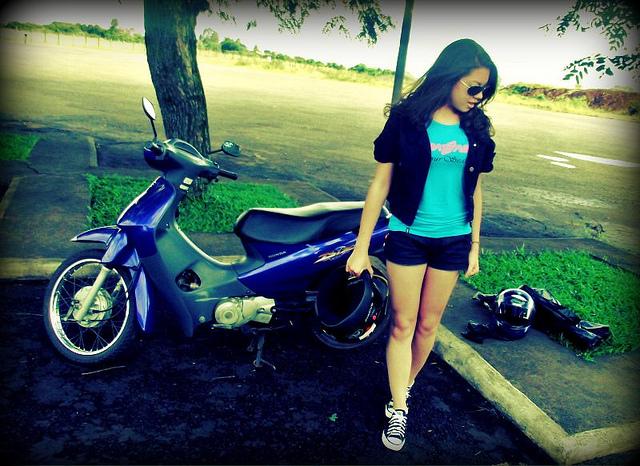What's the dome-shaped object lying behind the scooter?
Short answer required. Helmet. What's the color of the scooter?
Be succinct. Blue. What brand of sneakers is she wearing?
Be succinct. Converse. 